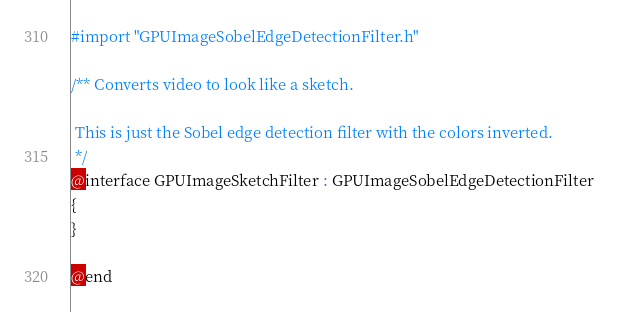Convert code to text. <code><loc_0><loc_0><loc_500><loc_500><_C_>#import "GPUImageSobelEdgeDetectionFilter.h"

/** Converts video to look like a sketch.
 
 This is just the Sobel edge detection filter with the colors inverted.
 */
@interface GPUImageSketchFilter : GPUImageSobelEdgeDetectionFilter
{
}

@end
</code> 